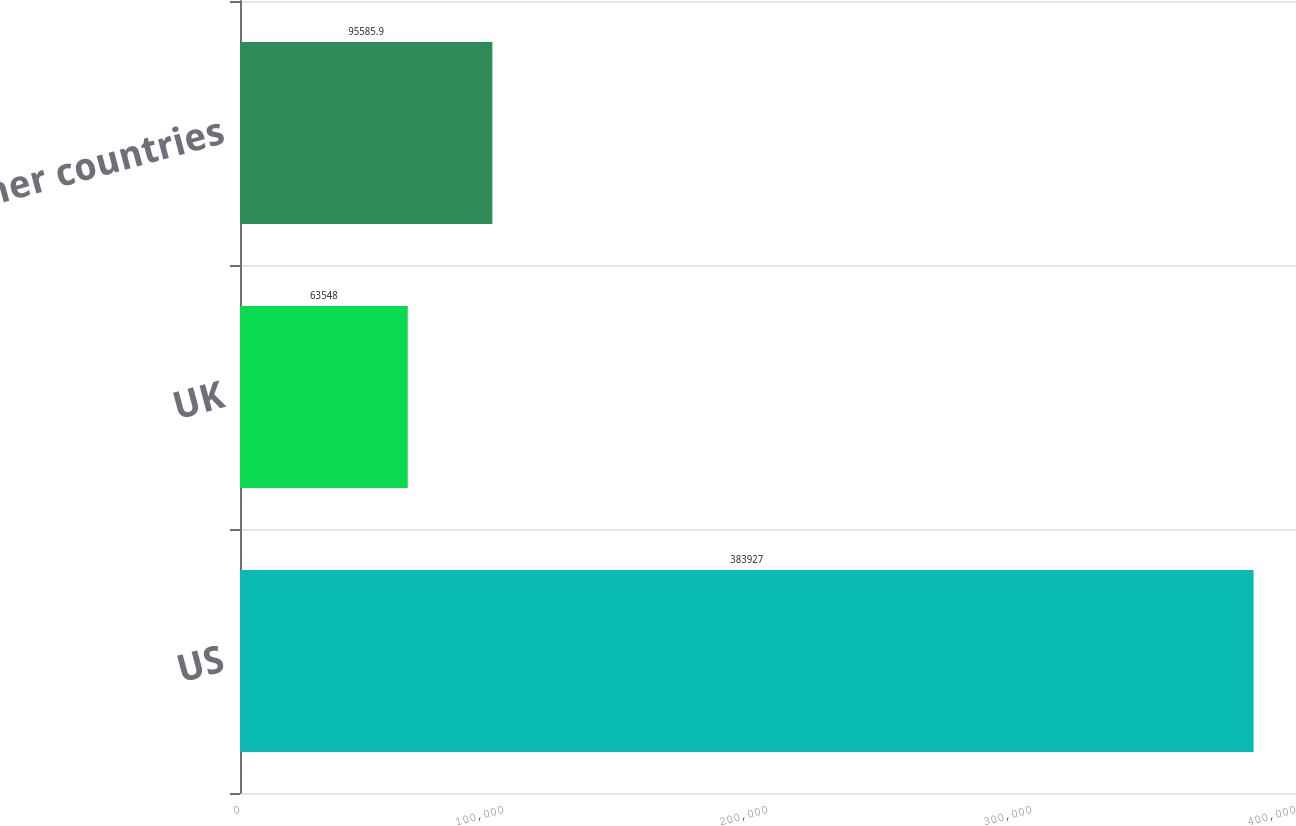Convert chart to OTSL. <chart><loc_0><loc_0><loc_500><loc_500><bar_chart><fcel>US<fcel>UK<fcel>All other countries<nl><fcel>383927<fcel>63548<fcel>95585.9<nl></chart> 